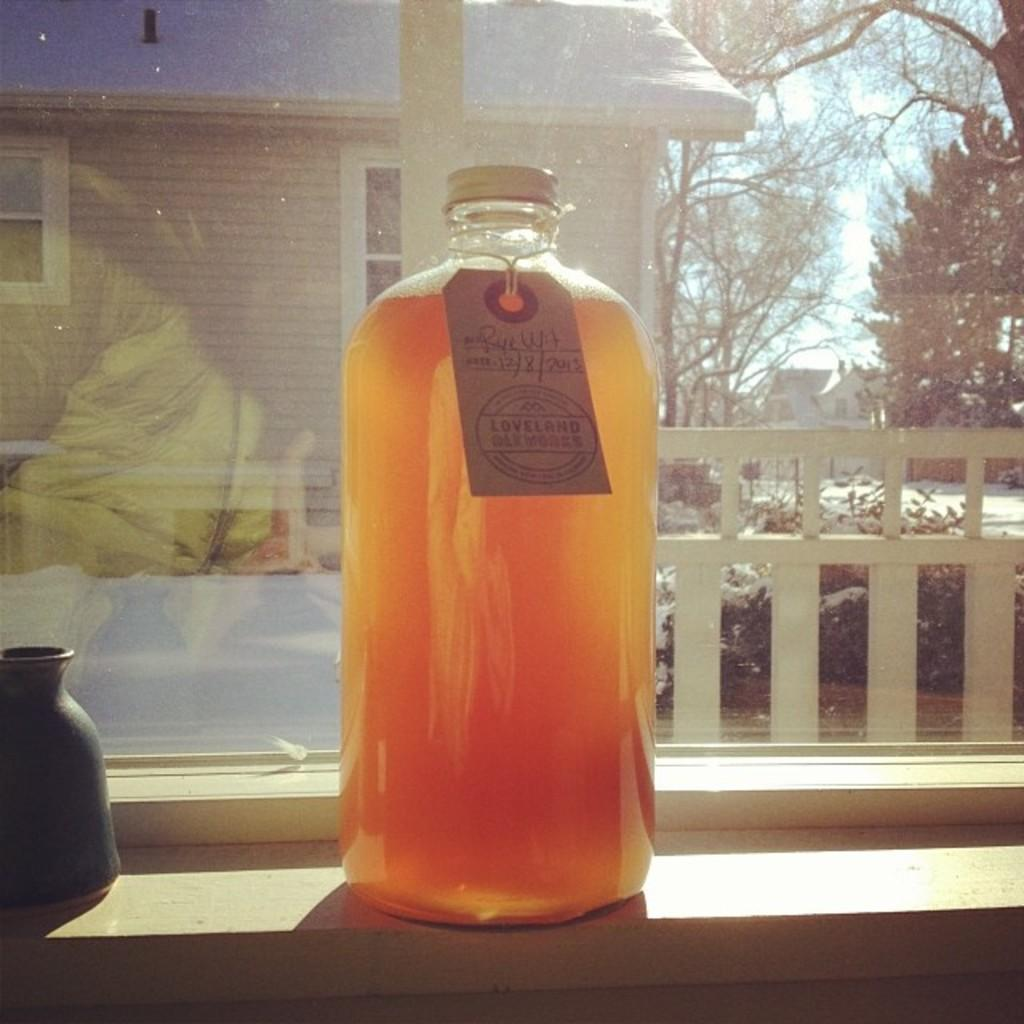<image>
Offer a succinct explanation of the picture presented. A concoction in a bottle labeled "Loveland" sits in a windowsill. 